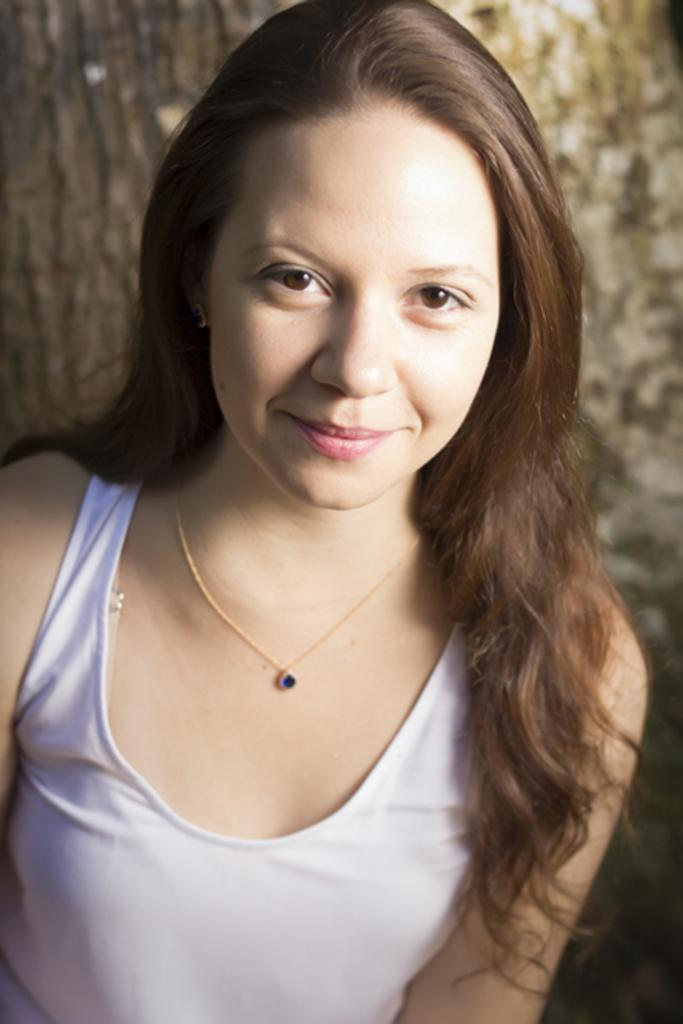Who is the main subject in the foreground of the image? There is a woman in the foreground of the image. What is the woman wearing? The woman is wearing a dress. What is the woman's facial expression in the image? The woman is smiling. What can be seen in the background of the image? The background of the image includes the trunk of a tree and other objects. What type of cloud is visible in the image? There is no cloud visible in the image; it only includes the trunk of a tree and other objects in the background. What is the woman using to carry a heavy load in the image? There is no yoke or heavy load present in the image; the woman is simply standing and smiling. 